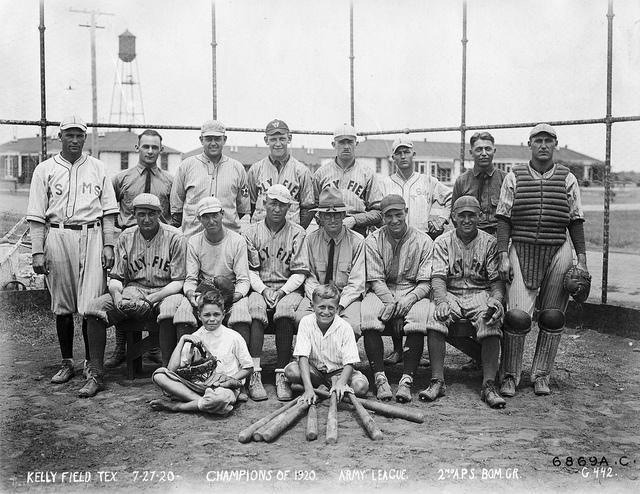What role does the most heavily armored person shown here hold?
From the following set of four choices, select the accurate answer to respond to the question.
Options: Runner, pitcher, catcher, batter. Catcher. 